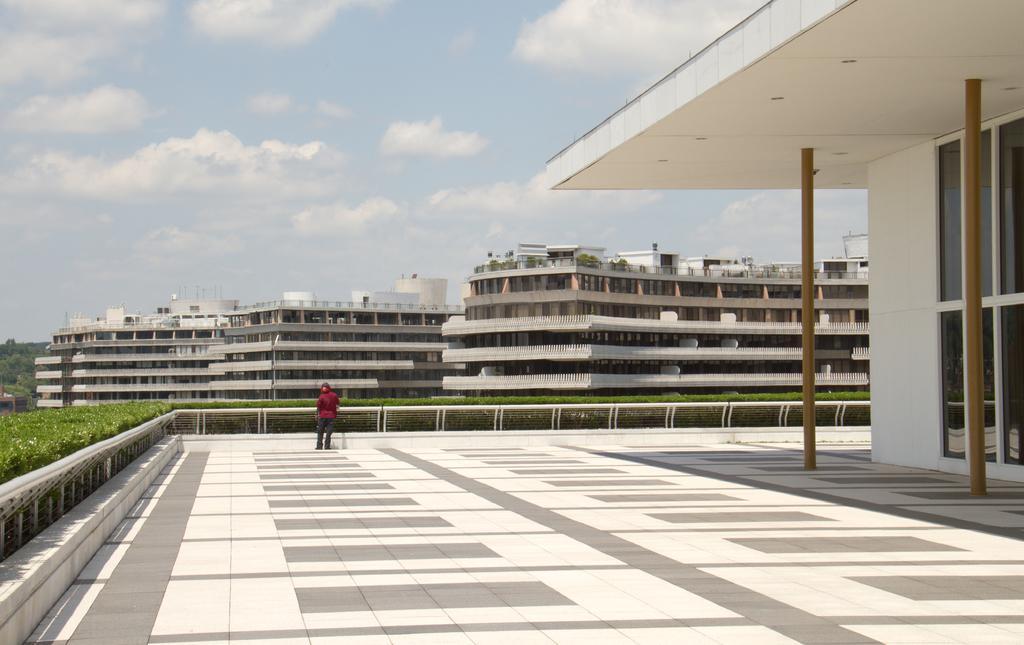In one or two sentences, can you explain what this image depicts? Here in this picture we can see a person standing over a place and in front of him we can see railing covered all over there and we can see plants present and in front of him we can see number of buildings present over there and in the far we can see trees present and we can see clouds in the sky and on the right side we can also see a house present over there. 